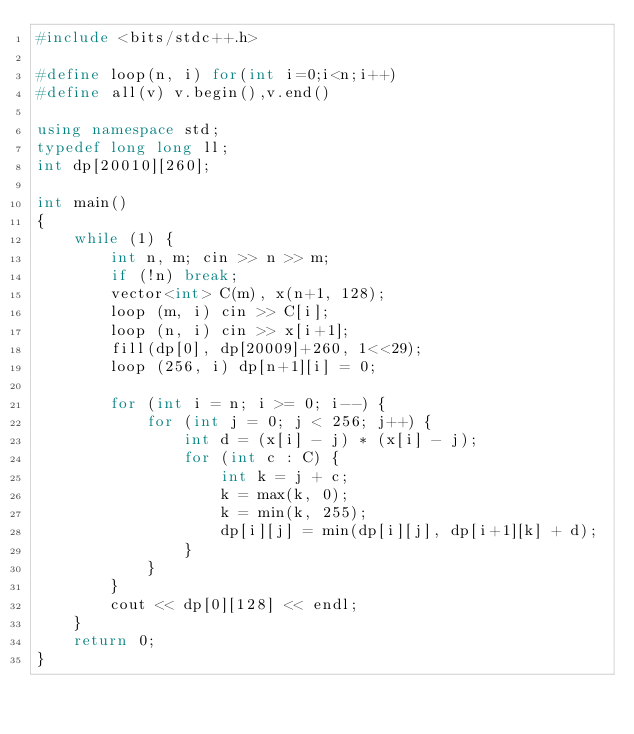Convert code to text. <code><loc_0><loc_0><loc_500><loc_500><_C++_>#include <bits/stdc++.h>
 
#define loop(n, i) for(int i=0;i<n;i++)
#define all(v) v.begin(),v.end()

using namespace std;
typedef long long ll;
int dp[20010][260];

int main()
{
    while (1) {
        int n, m; cin >> n >> m;
        if (!n) break;
        vector<int> C(m), x(n+1, 128);
        loop (m, i) cin >> C[i];
        loop (n, i) cin >> x[i+1];
        fill(dp[0], dp[20009]+260, 1<<29);
        loop (256, i) dp[n+1][i] = 0;

        for (int i = n; i >= 0; i--) {
            for (int j = 0; j < 256; j++) {
                int d = (x[i] - j) * (x[i] - j);
                for (int c : C) {
                    int k = j + c;
                    k = max(k, 0);
                    k = min(k, 255);
                    dp[i][j] = min(dp[i][j], dp[i+1][k] + d);
                }
            }
        }
        cout << dp[0][128] << endl;
    }
    return 0;
}</code> 